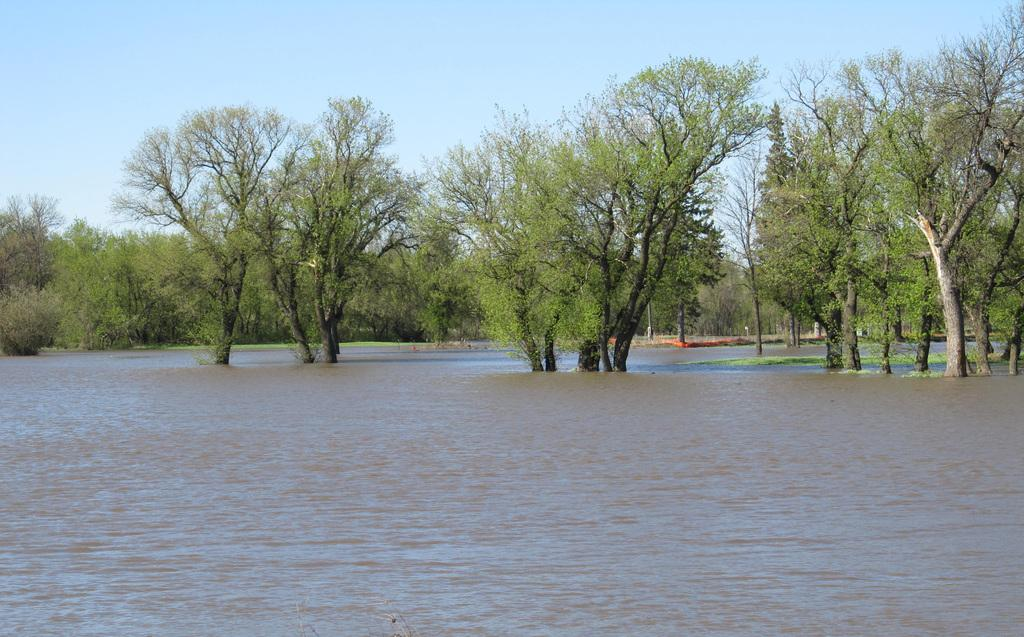What type of natural feature is at the bottom of the image? There is a river at the bottom of the image. What can be seen in the background of the image? There are many trees in the background of the image. What is visible at the top of the image? The sky is visible at the top of the image. What type of string can be seen connecting the trees in the image? There is no string connecting the trees in the image; only the trees and the river are present. Can you hear the thunder in the image? There is no sound in the image, so it is not possible to hear thunder. 